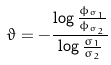Convert formula to latex. <formula><loc_0><loc_0><loc_500><loc_500>\vartheta = - \frac { \log \frac { \phi _ { \varsigma _ { 1 } } } { \phi _ { \varsigma _ { 2 } } } } { \log \frac { \varsigma _ { 1 } } { \varsigma _ { 2 } } }</formula> 